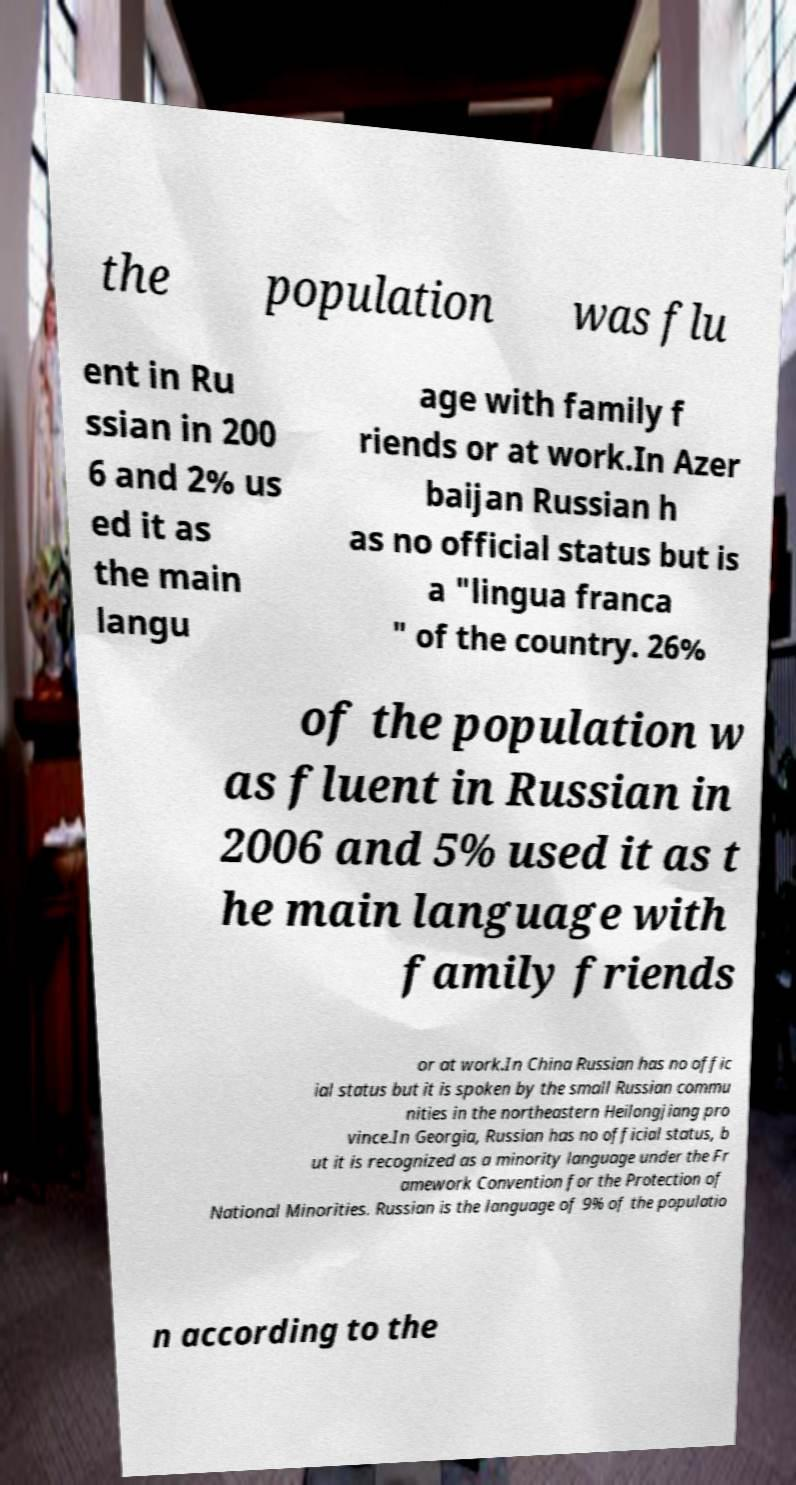Could you extract and type out the text from this image? the population was flu ent in Ru ssian in 200 6 and 2% us ed it as the main langu age with family f riends or at work.In Azer baijan Russian h as no official status but is a "lingua franca " of the country. 26% of the population w as fluent in Russian in 2006 and 5% used it as t he main language with family friends or at work.In China Russian has no offic ial status but it is spoken by the small Russian commu nities in the northeastern Heilongjiang pro vince.In Georgia, Russian has no official status, b ut it is recognized as a minority language under the Fr amework Convention for the Protection of National Minorities. Russian is the language of 9% of the populatio n according to the 